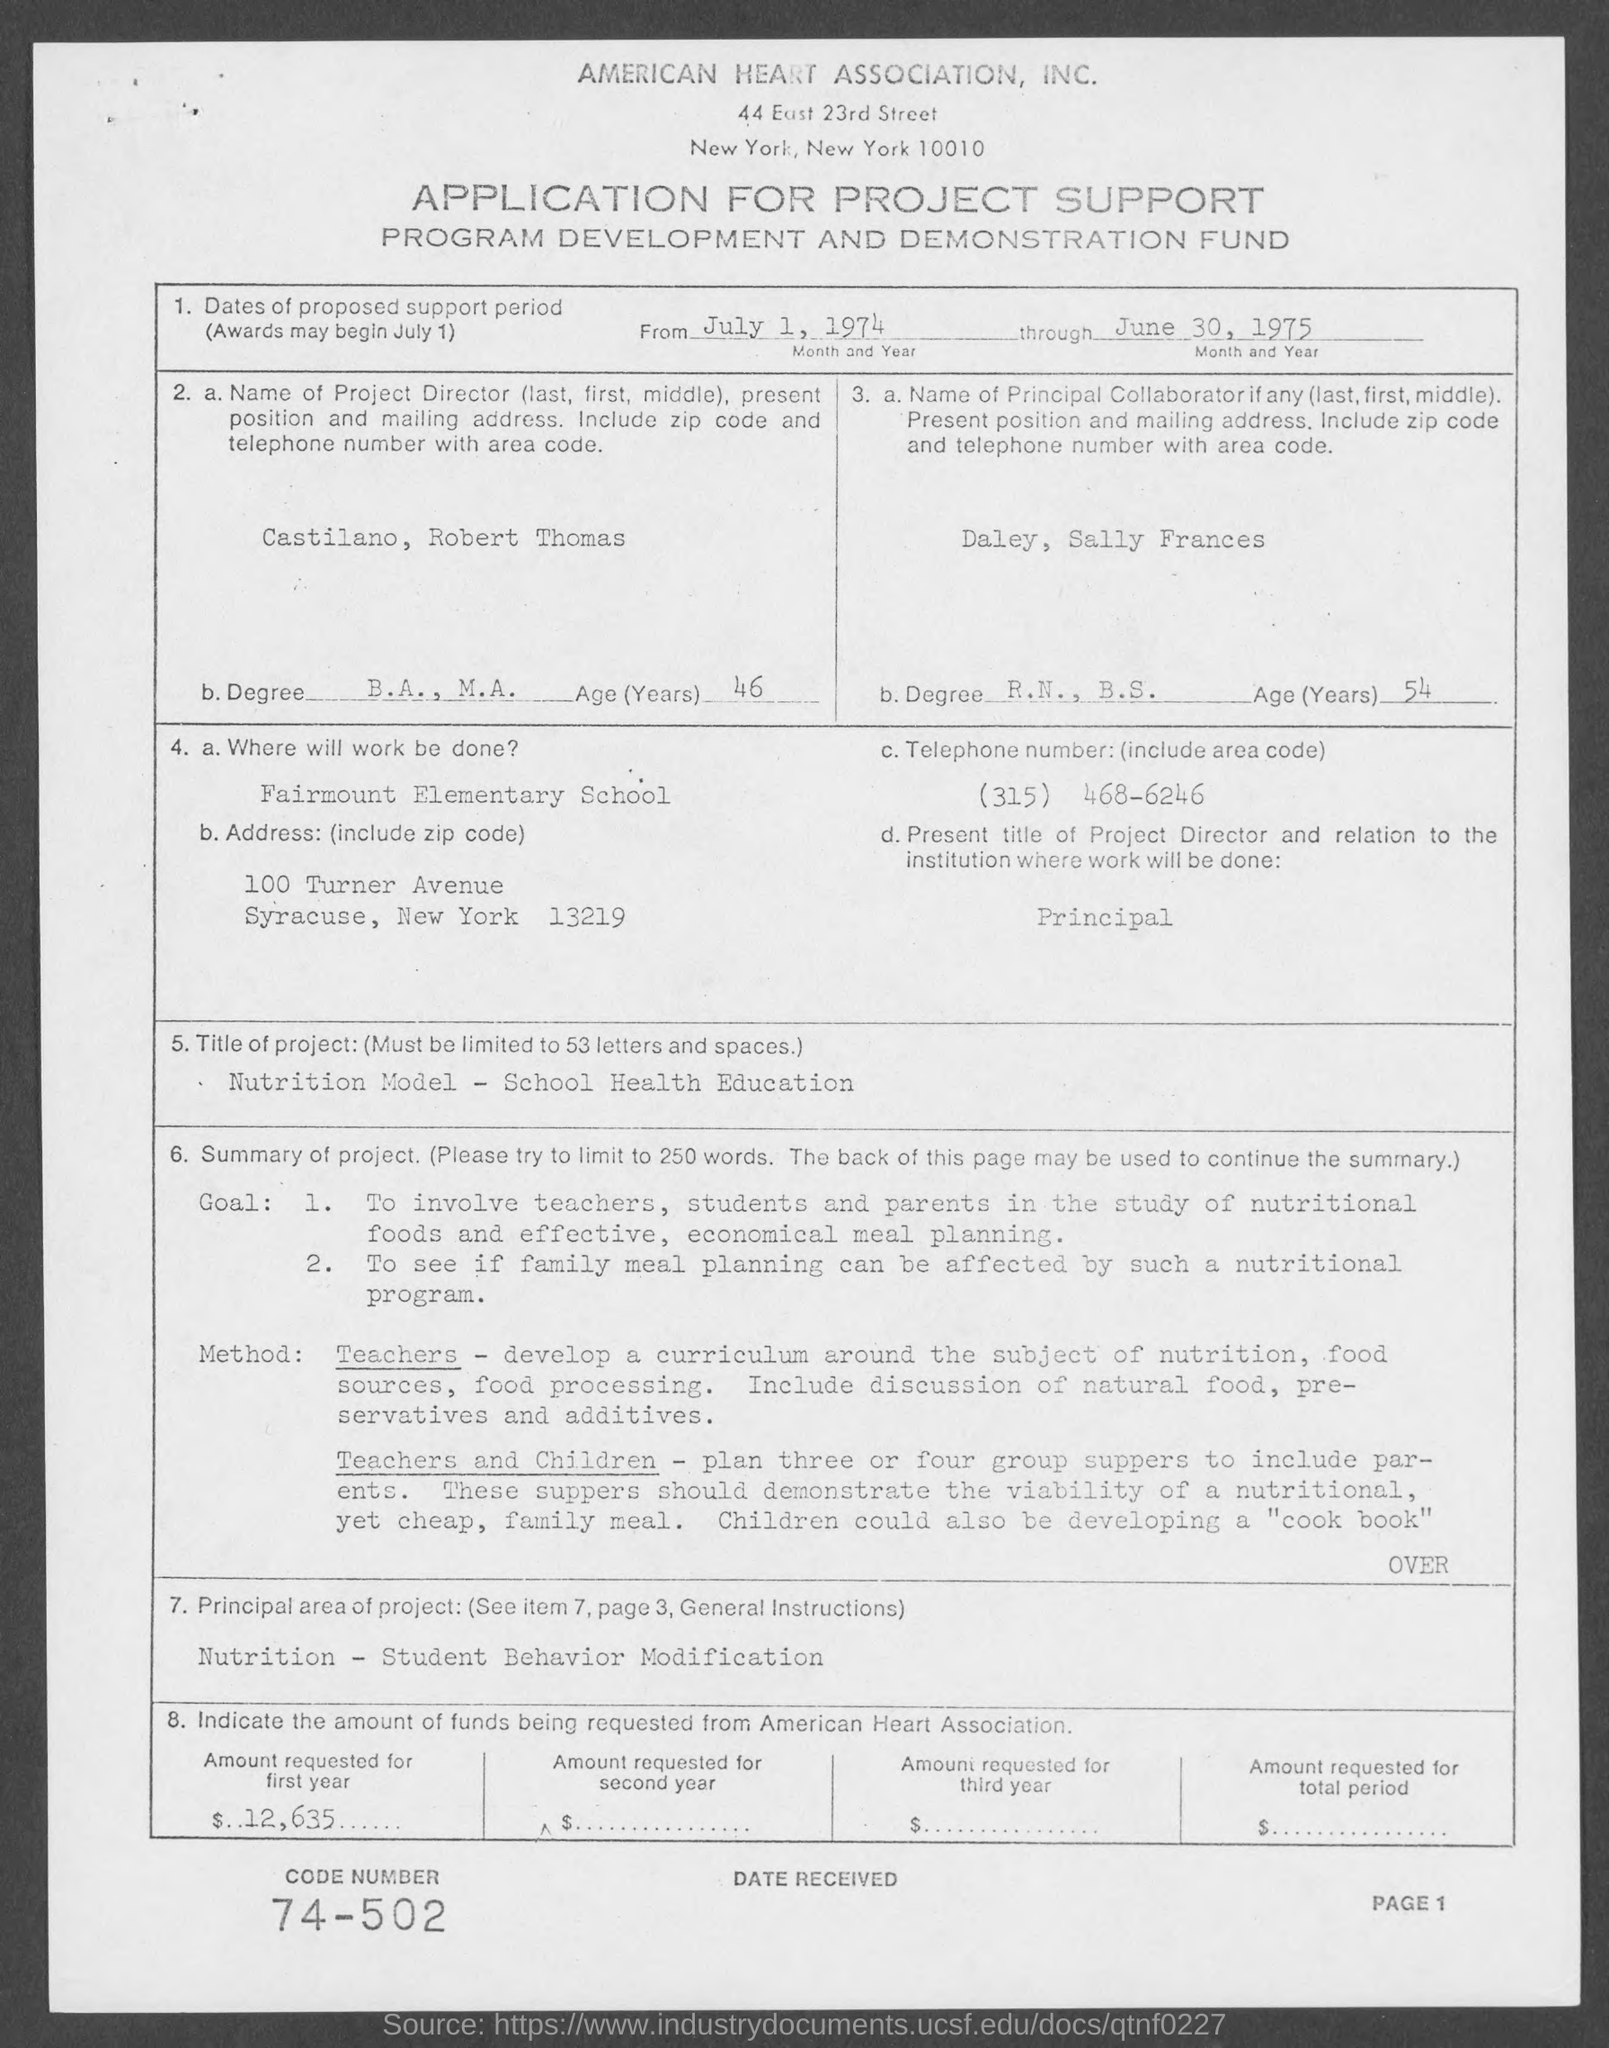Highlight a few significant elements in this photo. The American Heart Association is the name of the association mentioned in the given page. R.N., B.S. is the degree earned by Daley, as mentioned in the given page. The code number mentioned in the provided page is 74-502. Robert Thomas, mentioned in the given page, is 46 years old. Castilano, Robert Thomas, as mentioned in the given page, has completed a degree in B.A., M.A.. 